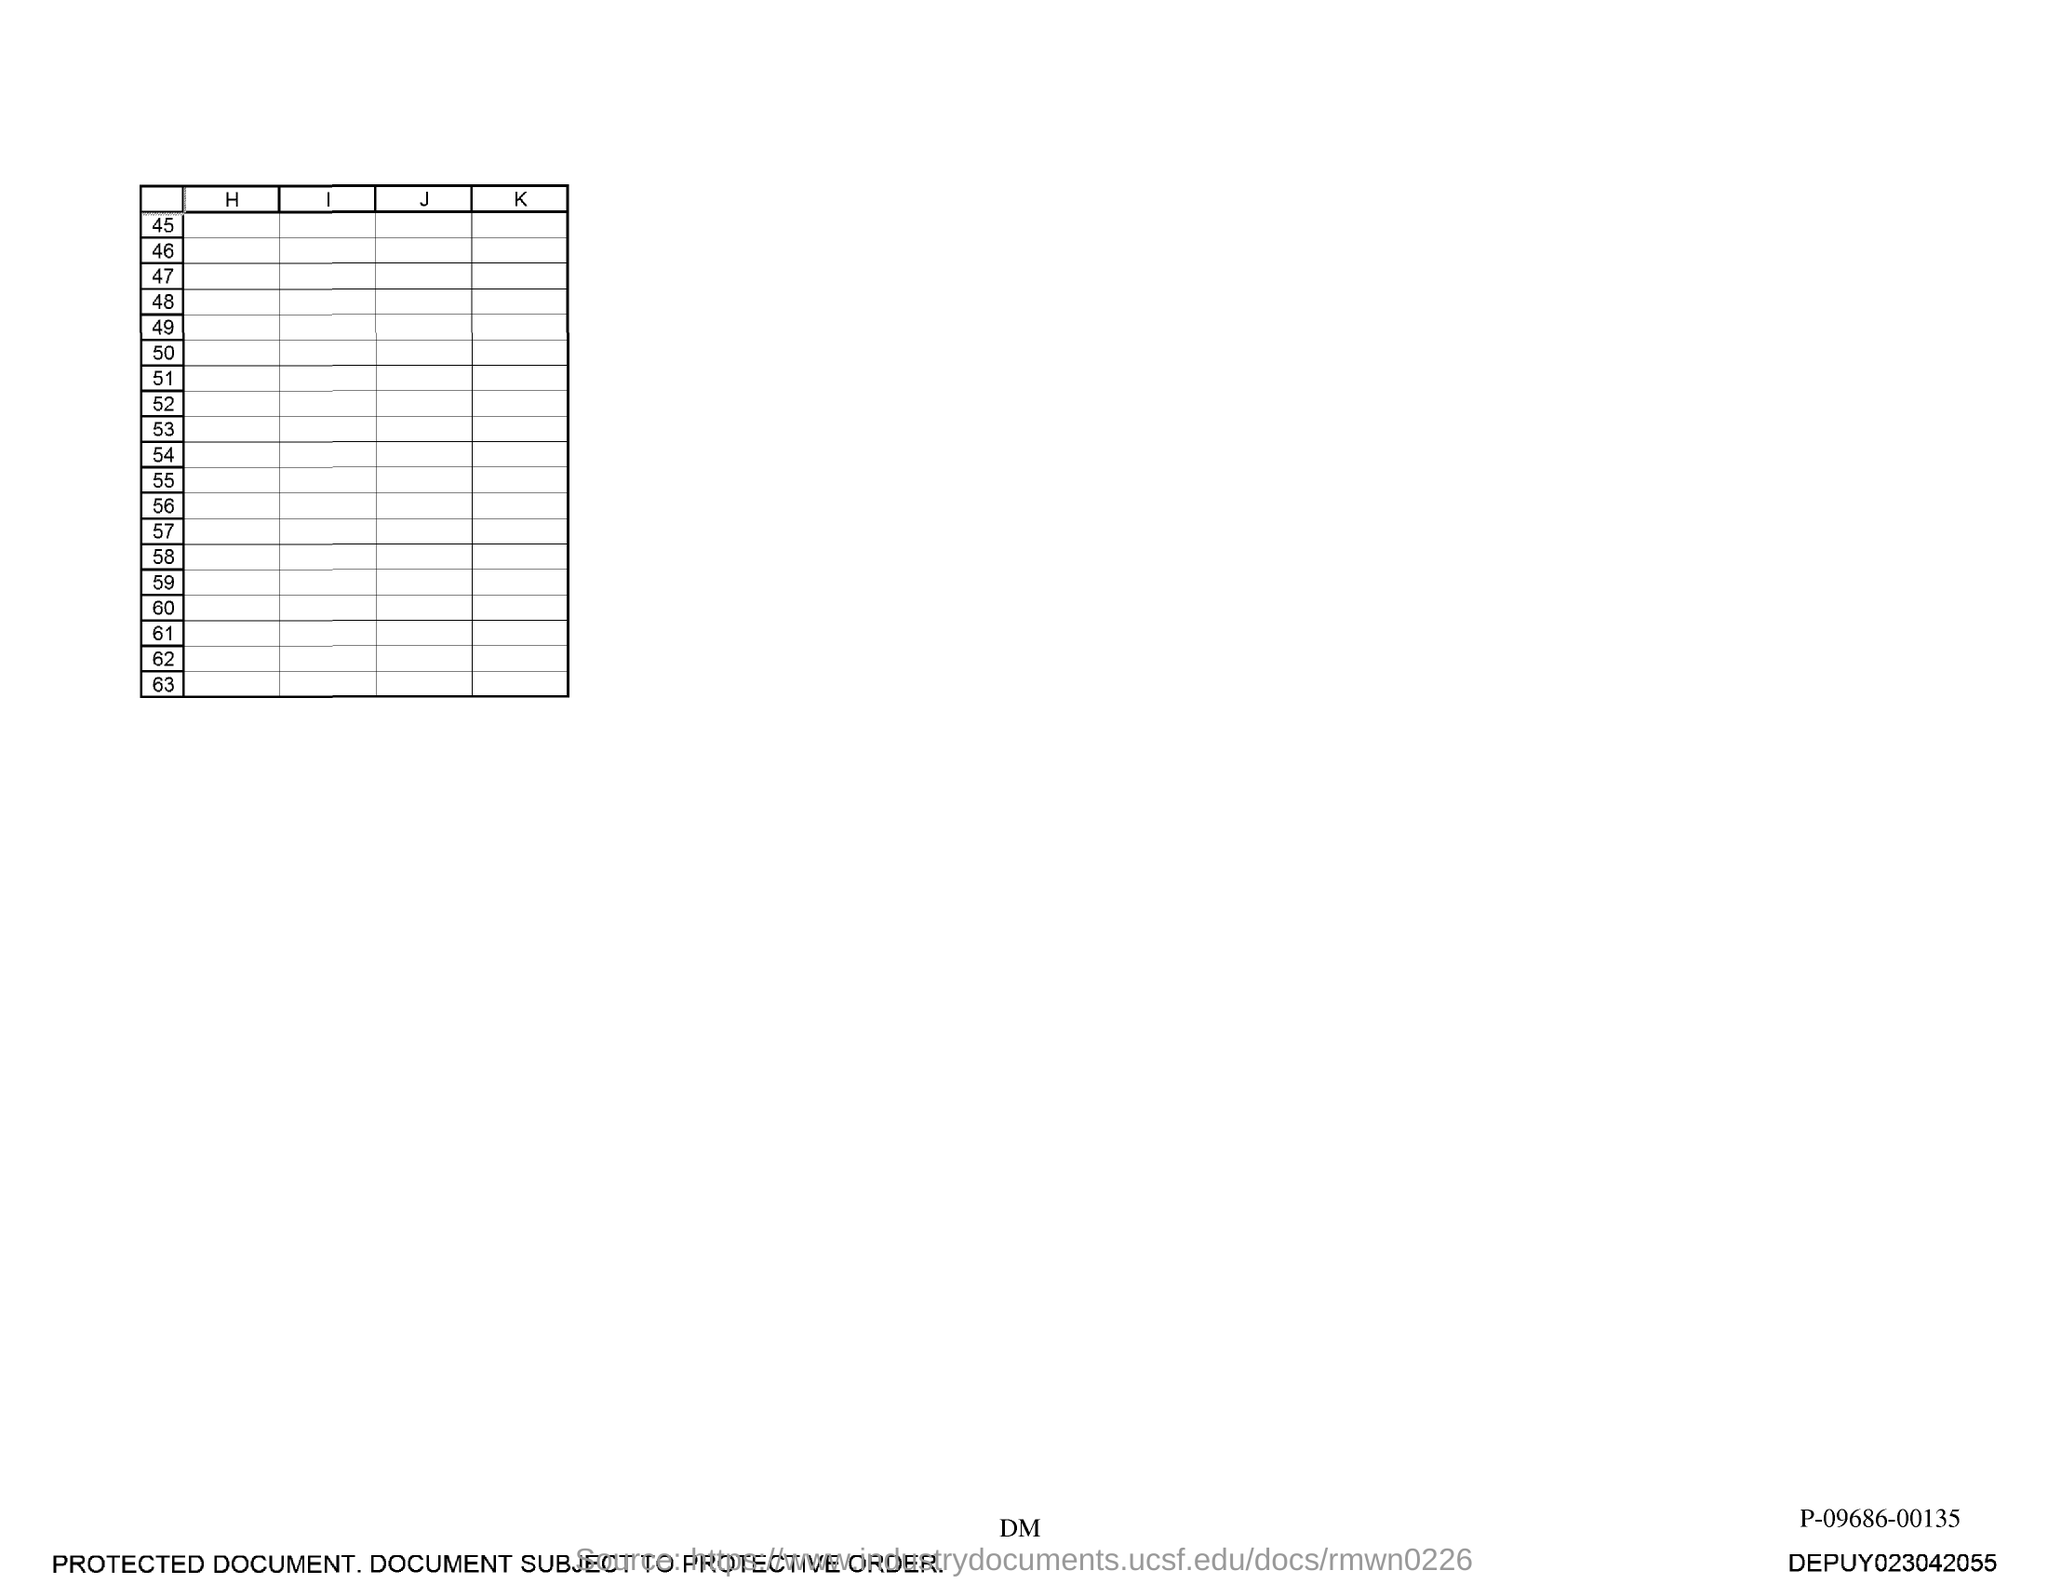What is the last number in the first column?
Your response must be concise. 63. 